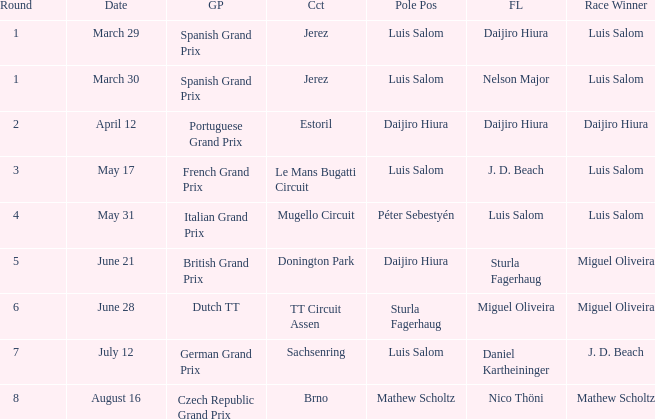What grand prixs did Daijiro Hiura win?  Portuguese Grand Prix. 